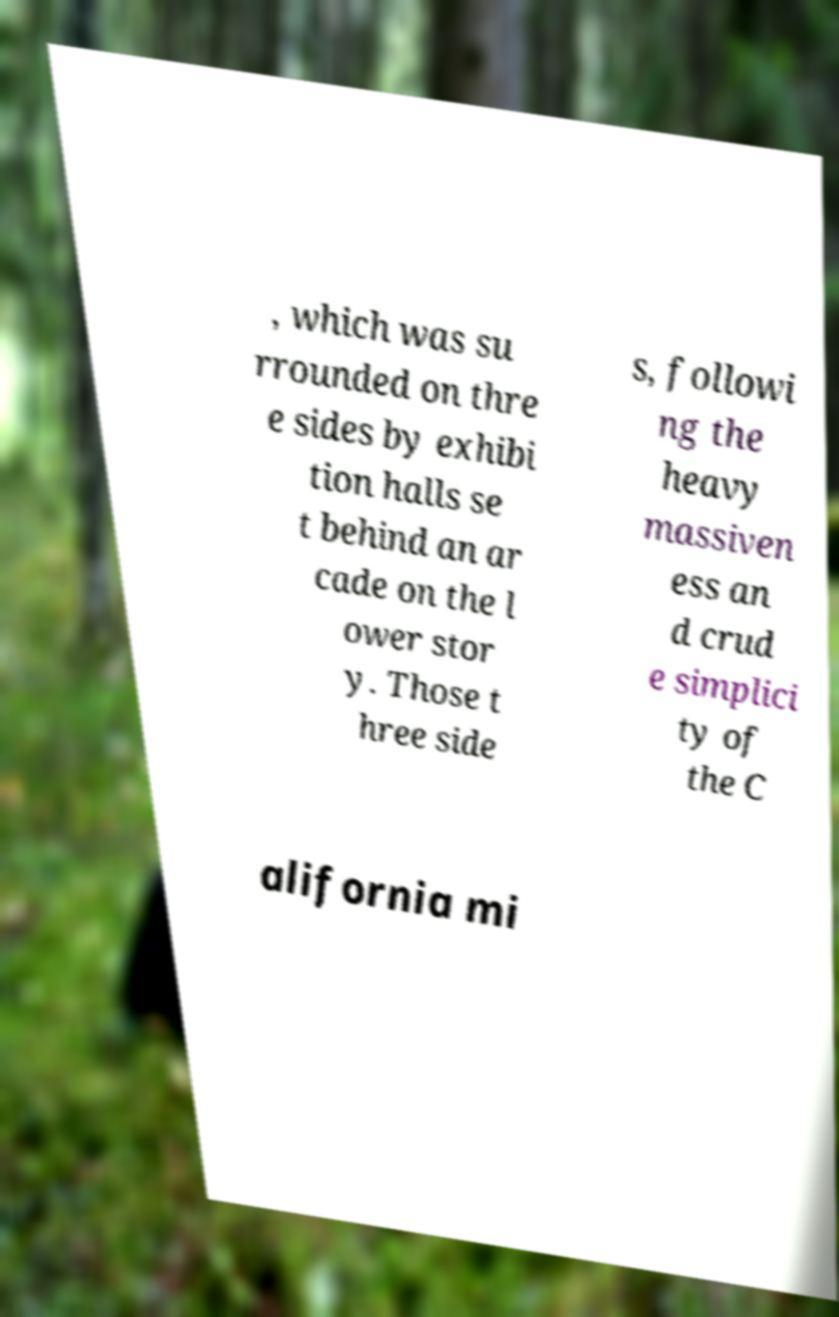Can you read and provide the text displayed in the image?This photo seems to have some interesting text. Can you extract and type it out for me? , which was su rrounded on thre e sides by exhibi tion halls se t behind an ar cade on the l ower stor y. Those t hree side s, followi ng the heavy massiven ess an d crud e simplici ty of the C alifornia mi 